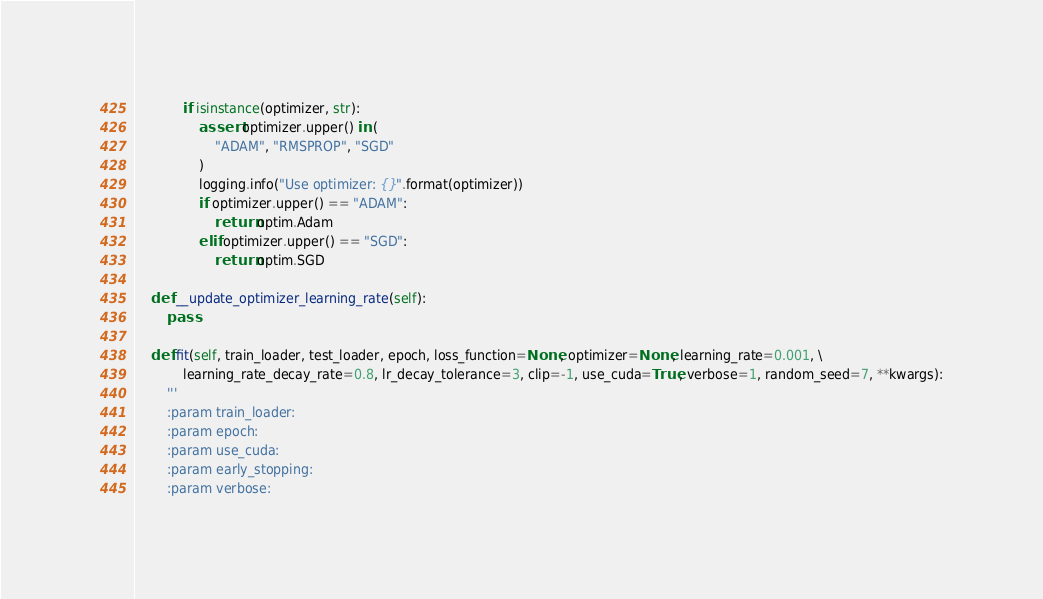<code> <loc_0><loc_0><loc_500><loc_500><_Python_>            if isinstance(optimizer, str):
                assert optimizer.upper() in (
                    "ADAM", "RMSPROP", "SGD"
                )
                logging.info("Use optimizer: {}".format(optimizer))
                if optimizer.upper() == "ADAM":
                    return optim.Adam
                elif optimizer.upper() == "SGD":
                    return optim.SGD

    def __update_optimizer_learning_rate(self):
        pass

    def fit(self, train_loader, test_loader, epoch, loss_function=None, optimizer=None, learning_rate=0.001, \
            learning_rate_decay_rate=0.8, lr_decay_tolerance=3, clip=-1, use_cuda=True, verbose=1, random_seed=7, **kwargs):
        '''
        :param train_loader:
        :param epoch:
        :param use_cuda:
        :param early_stopping:
        :param verbose:</code> 